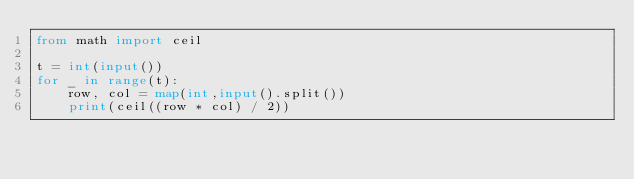Convert code to text. <code><loc_0><loc_0><loc_500><loc_500><_Python_>from math import ceil

t = int(input())
for _ in range(t):
    row, col = map(int,input().split())
    print(ceil((row * col) / 2))</code> 